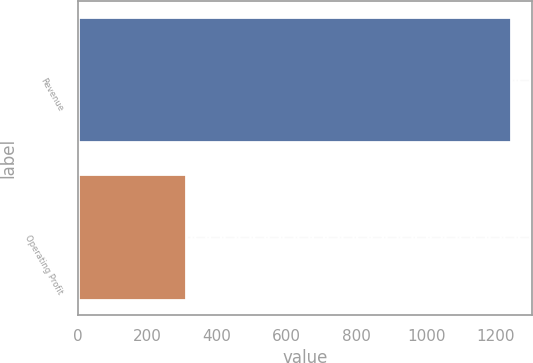Convert chart. <chart><loc_0><loc_0><loc_500><loc_500><bar_chart><fcel>Revenue<fcel>Operating Profit<nl><fcel>1241.8<fcel>309.5<nl></chart> 